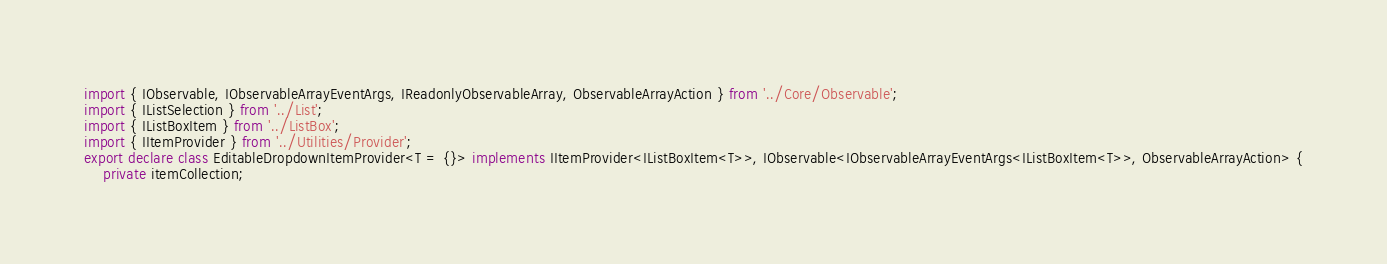<code> <loc_0><loc_0><loc_500><loc_500><_TypeScript_>import { IObservable, IObservableArrayEventArgs, IReadonlyObservableArray, ObservableArrayAction } from '../Core/Observable';
import { IListSelection } from '../List';
import { IListBoxItem } from '../ListBox';
import { IItemProvider } from '../Utilities/Provider';
export declare class EditableDropdownItemProvider<T = {}> implements IItemProvider<IListBoxItem<T>>, IObservable<IObservableArrayEventArgs<IListBoxItem<T>>, ObservableArrayAction> {
    private itemCollection;</code> 